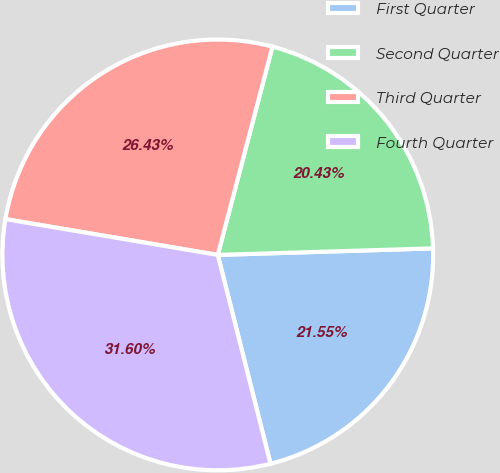Convert chart to OTSL. <chart><loc_0><loc_0><loc_500><loc_500><pie_chart><fcel>First Quarter<fcel>Second Quarter<fcel>Third Quarter<fcel>Fourth Quarter<nl><fcel>21.55%<fcel>20.43%<fcel>26.43%<fcel>31.6%<nl></chart> 